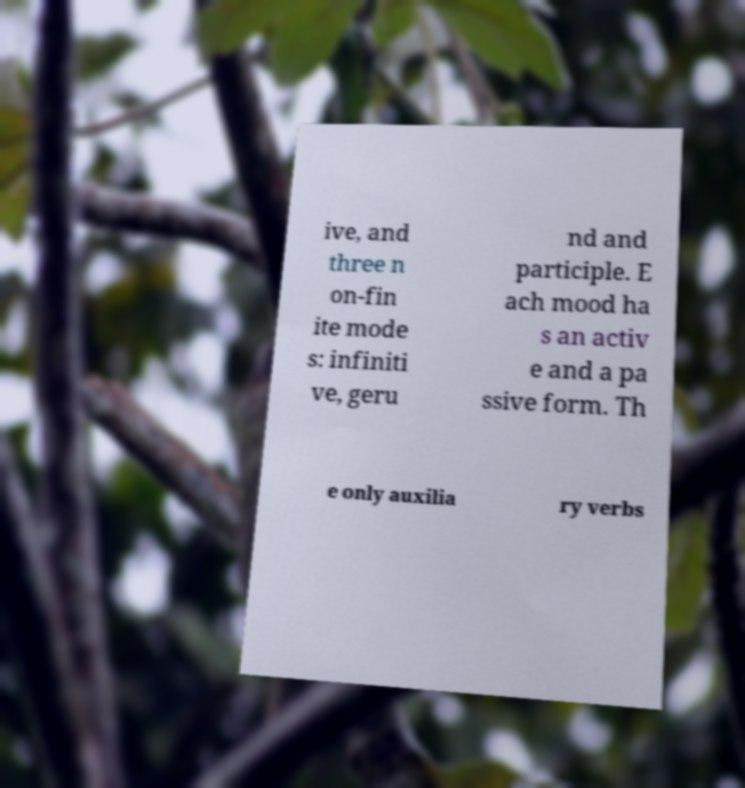Please read and relay the text visible in this image. What does it say? ive, and three n on-fin ite mode s: infiniti ve, geru nd and participle. E ach mood ha s an activ e and a pa ssive form. Th e only auxilia ry verbs 